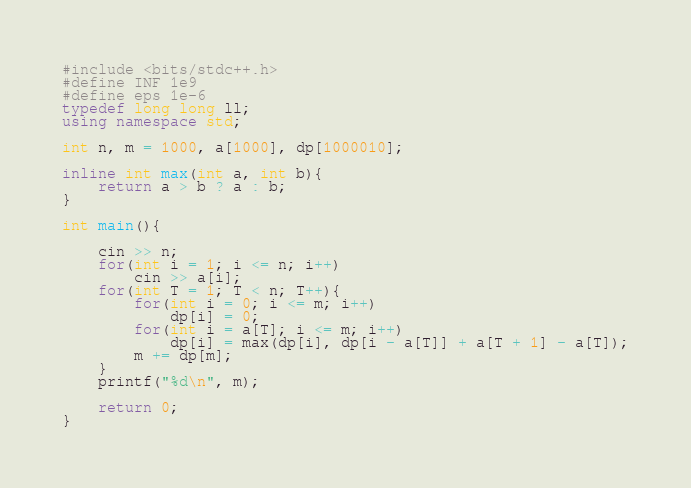<code> <loc_0><loc_0><loc_500><loc_500><_C++_>#include <bits/stdc++.h>
#define INF 1e9
#define eps 1e-6
typedef long long ll;
using namespace std;

int n, m = 1000, a[1000], dp[1000010];

inline int max(int a, int b){
	return a > b ? a : b;
}

int main(){

	cin >> n;
	for(int i = 1; i <= n; i++)
		cin >> a[i];
	for(int T = 1; T < n; T++){
		for(int i = 0; i <= m; i++)	
			dp[i] = 0;
		for(int i = a[T]; i <= m; i++)
			dp[i] = max(dp[i], dp[i - a[T]] + a[T + 1] - a[T]);
		m += dp[m];
	}
	printf("%d\n", m);

	return 0;
}</code> 